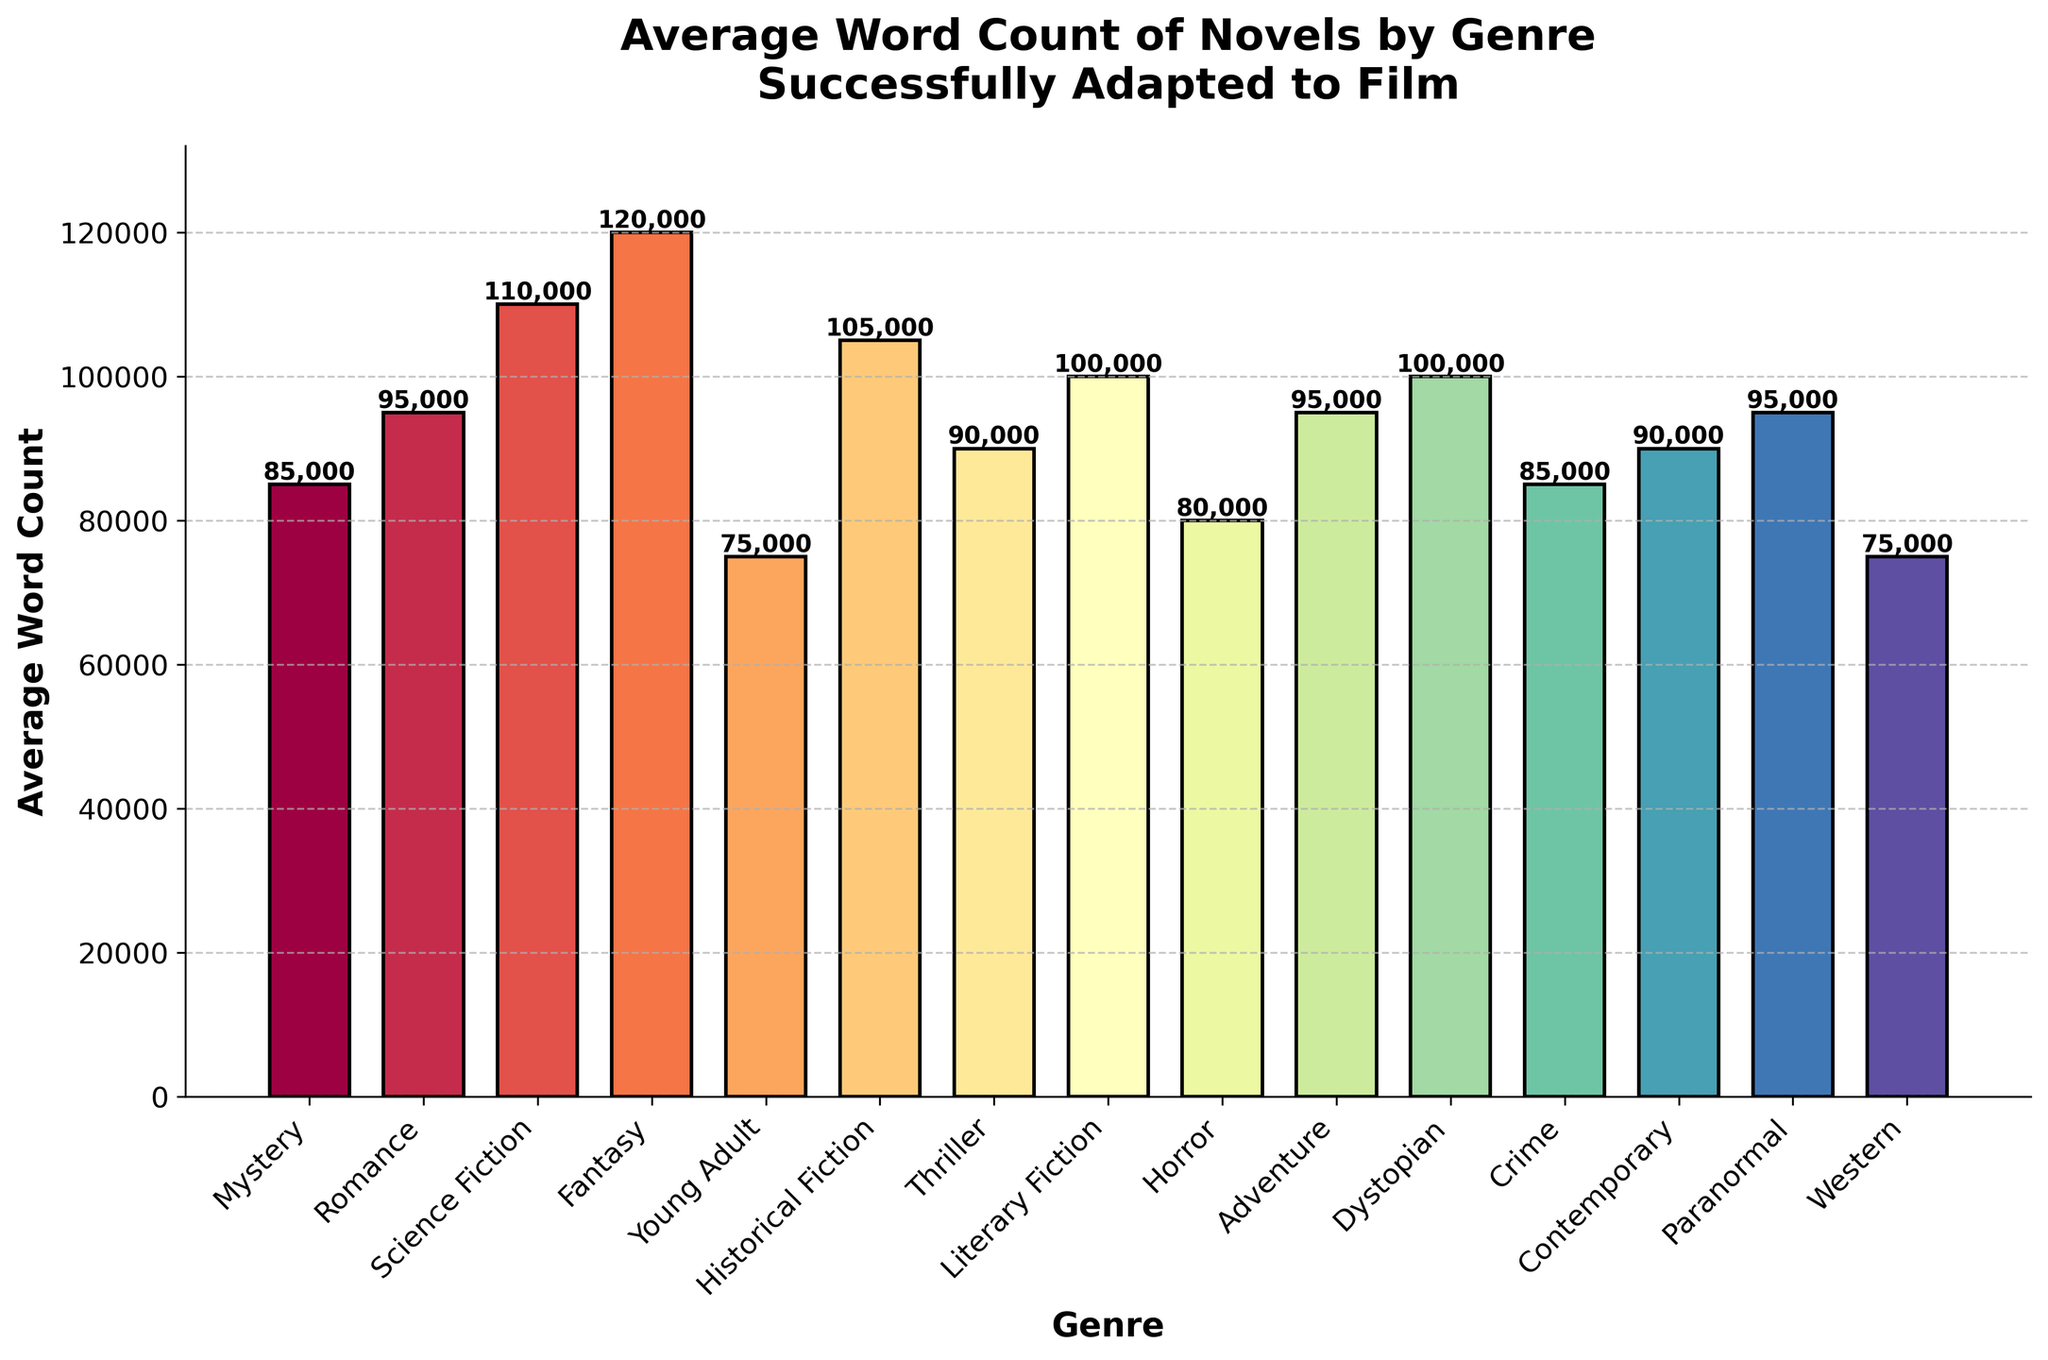Which genre has the highest average word count? Examine all the bars and identify the one with the tallest height, which corresponds to Fantasy with an average word count of 120,000.
Answer: Fantasy What is the difference in average word count between Science Fiction and Romance? Locate the bar for Science Fiction (110,000) and the bar for Romance (95,000). Subtract 95,000 from 110,000.
Answer: 15,000 Which genres have an average word count greater than 100,000? Identify the bars exceeding the 100,000 mark: Science Fiction (110,000), Fantasy (120,000), and Historical Fiction (105,000).
Answer: Science Fiction, Fantasy, and Historical Fiction What is the average word count of Mystery and Crime genres combined? Locate the bars for Mystery (85,000) and Crime (85,000). Sum them up and then average: (85,000 + 85,000) / 2.
Answer: 85,000 How does the average word count of Young Adult compare to Western? Locate the bars for Young Adult (75,000) and Western (75,000), and note they are of equal height.
Answer: Equal Which genre is represented by the darkest color on the bar chart? Identify the bar with the darkest color by visual inspection, corresponding to Fantasy.
Answer: Fantasy Is the average word count of Horror higher or lower than that of Thriller? Compare the heights of the Horror (80,000) and Thriller (90,000) bars, noting that Thriller is higher.
Answer: Lower What’s the total average word count of Adventure, Paranormal, and Romance genres? Sum the word counts for Adventure (95,000), Paranormal (95,000), and Romance (95,000): 95,000 + 95,000 + 95,000.
Answer: 285,000 Which genre has the lowest average word count? Examine the bars and identify the lowest one, corresponding to Young Adult and Western (both 75,000).
Answer: Young Adult and Western What is the combined average word count of Literary Fiction and Contemporary genres? Locate the bars for Literary Fiction (100,000) and Contemporary (90,000). Sum them up: 100,000 + 90,000.
Answer: 190,000 